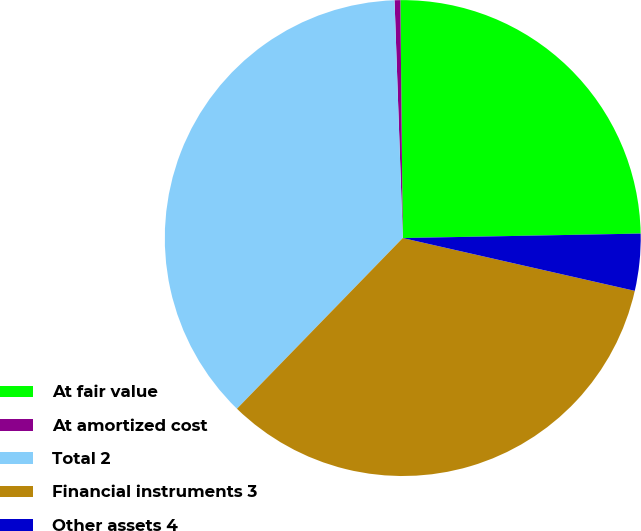Convert chart to OTSL. <chart><loc_0><loc_0><loc_500><loc_500><pie_chart><fcel>At fair value<fcel>At amortized cost<fcel>Total 2<fcel>Financial instruments 3<fcel>Other assets 4<nl><fcel>24.86%<fcel>0.39%<fcel>37.18%<fcel>33.71%<fcel>3.86%<nl></chart> 